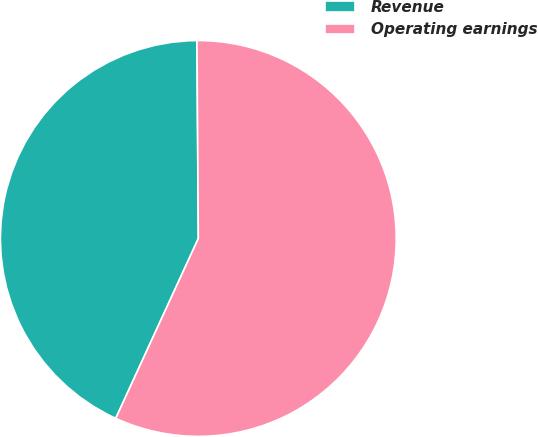Convert chart to OTSL. <chart><loc_0><loc_0><loc_500><loc_500><pie_chart><fcel>Revenue<fcel>Operating earnings<nl><fcel>43.04%<fcel>56.96%<nl></chart> 